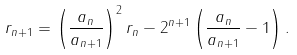<formula> <loc_0><loc_0><loc_500><loc_500>r _ { n + 1 } = \left ( \frac { a _ { n } } { a _ { n + 1 } } \right ) ^ { 2 } r _ { n } - 2 ^ { n + 1 } \left ( \frac { a _ { n } } { a _ { n + 1 } } - 1 \right ) .</formula> 